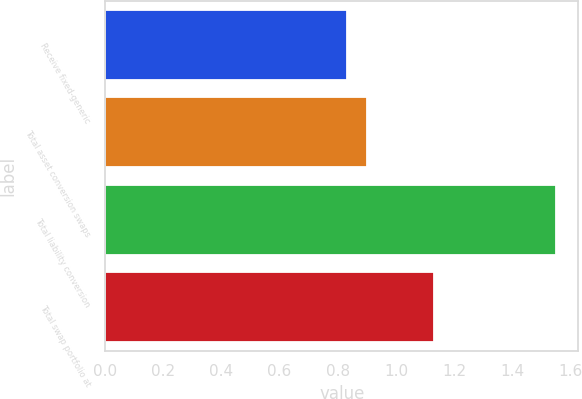Convert chart. <chart><loc_0><loc_0><loc_500><loc_500><bar_chart><fcel>Receive fixed-generic<fcel>Total asset conversion swaps<fcel>Total liability conversion<fcel>Total swap portfolio at<nl><fcel>0.83<fcel>0.9<fcel>1.55<fcel>1.13<nl></chart> 